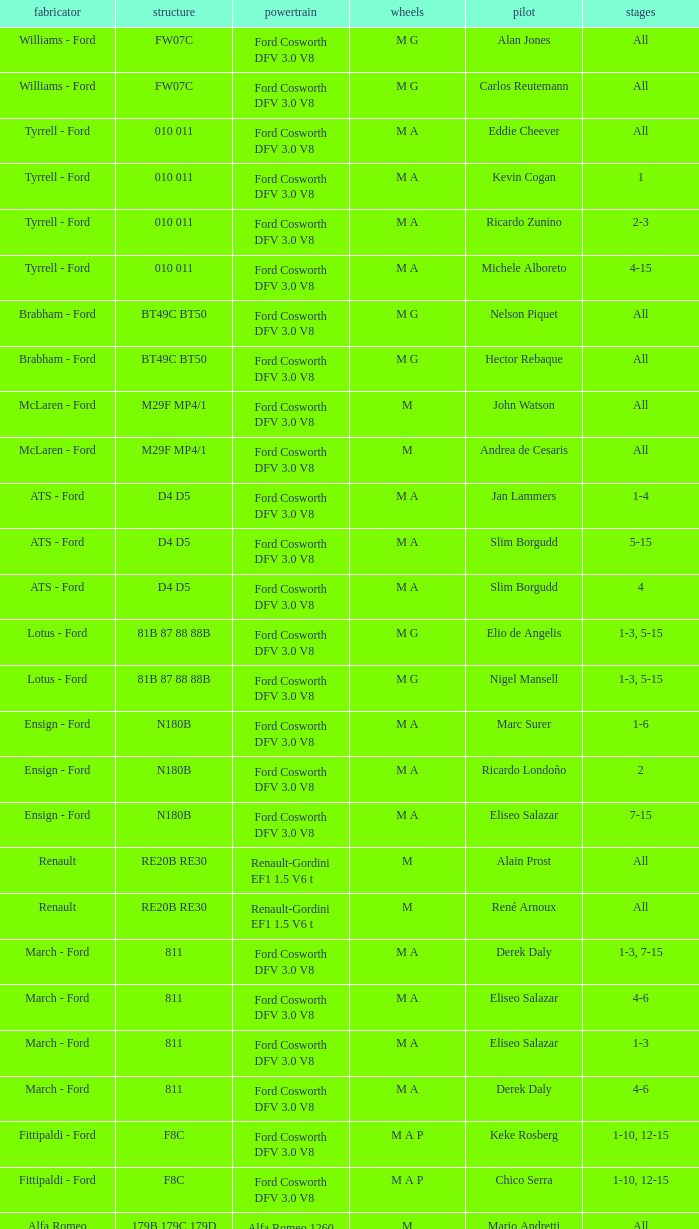Who constructed the car that Derek Warwick raced in with a TG181 chassis? Toleman - Hart. 